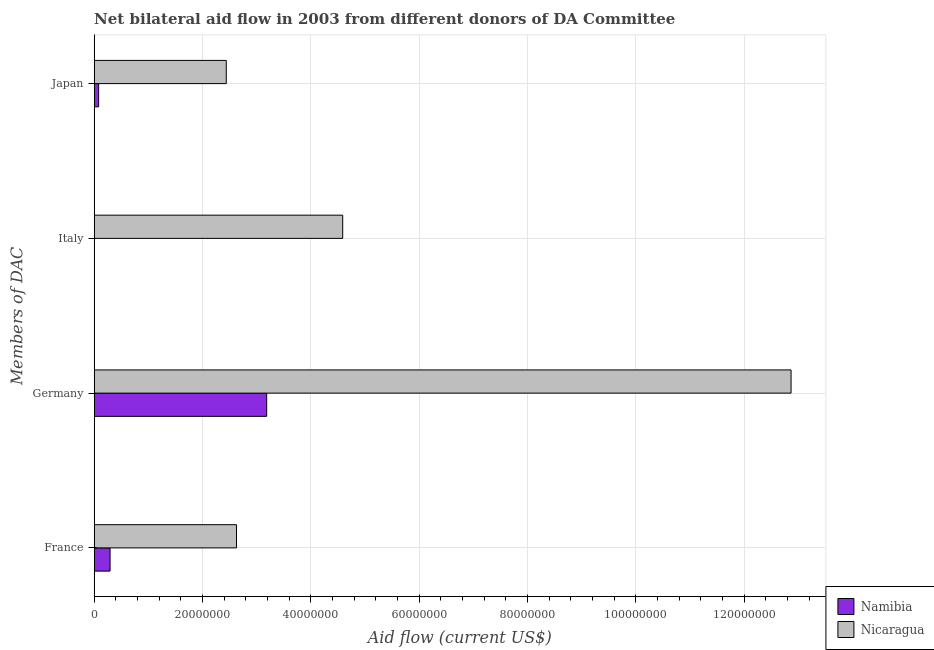How many bars are there on the 1st tick from the bottom?
Keep it short and to the point. 2. What is the label of the 3rd group of bars from the top?
Your answer should be very brief. Germany. What is the amount of aid given by germany in Namibia?
Ensure brevity in your answer.  3.18e+07. Across all countries, what is the maximum amount of aid given by france?
Offer a very short reply. 2.63e+07. Across all countries, what is the minimum amount of aid given by france?
Ensure brevity in your answer.  2.93e+06. In which country was the amount of aid given by japan maximum?
Give a very brief answer. Nicaragua. In which country was the amount of aid given by germany minimum?
Ensure brevity in your answer.  Namibia. What is the total amount of aid given by france in the graph?
Your response must be concise. 2.92e+07. What is the difference between the amount of aid given by italy in Nicaragua and that in Namibia?
Offer a terse response. 4.58e+07. What is the difference between the amount of aid given by japan in Nicaragua and the amount of aid given by france in Namibia?
Make the answer very short. 2.14e+07. What is the average amount of aid given by italy per country?
Give a very brief answer. 2.29e+07. What is the difference between the amount of aid given by germany and amount of aid given by france in Namibia?
Provide a succinct answer. 2.89e+07. What is the ratio of the amount of aid given by france in Namibia to that in Nicaragua?
Offer a very short reply. 0.11. Is the amount of aid given by france in Nicaragua less than that in Namibia?
Make the answer very short. No. Is the difference between the amount of aid given by italy in Nicaragua and Namibia greater than the difference between the amount of aid given by france in Nicaragua and Namibia?
Offer a very short reply. Yes. What is the difference between the highest and the second highest amount of aid given by italy?
Keep it short and to the point. 4.58e+07. What is the difference between the highest and the lowest amount of aid given by italy?
Your response must be concise. 4.58e+07. Is it the case that in every country, the sum of the amount of aid given by france and amount of aid given by japan is greater than the sum of amount of aid given by italy and amount of aid given by germany?
Offer a very short reply. No. What does the 2nd bar from the top in Japan represents?
Your answer should be very brief. Namibia. What does the 1st bar from the bottom in France represents?
Provide a succinct answer. Namibia. Is it the case that in every country, the sum of the amount of aid given by france and amount of aid given by germany is greater than the amount of aid given by italy?
Provide a succinct answer. Yes. How many bars are there?
Ensure brevity in your answer.  8. How many countries are there in the graph?
Offer a very short reply. 2. Are the values on the major ticks of X-axis written in scientific E-notation?
Offer a terse response. No. Does the graph contain grids?
Offer a terse response. Yes. How are the legend labels stacked?
Ensure brevity in your answer.  Vertical. What is the title of the graph?
Provide a succinct answer. Net bilateral aid flow in 2003 from different donors of DA Committee. Does "Papua New Guinea" appear as one of the legend labels in the graph?
Offer a terse response. No. What is the label or title of the X-axis?
Provide a short and direct response. Aid flow (current US$). What is the label or title of the Y-axis?
Ensure brevity in your answer.  Members of DAC. What is the Aid flow (current US$) of Namibia in France?
Provide a succinct answer. 2.93e+06. What is the Aid flow (current US$) of Nicaragua in France?
Make the answer very short. 2.63e+07. What is the Aid flow (current US$) in Namibia in Germany?
Offer a very short reply. 3.18e+07. What is the Aid flow (current US$) of Nicaragua in Germany?
Make the answer very short. 1.29e+08. What is the Aid flow (current US$) of Namibia in Italy?
Your answer should be compact. 2.00e+04. What is the Aid flow (current US$) of Nicaragua in Italy?
Give a very brief answer. 4.59e+07. What is the Aid flow (current US$) in Namibia in Japan?
Your answer should be compact. 8.20e+05. What is the Aid flow (current US$) in Nicaragua in Japan?
Your answer should be compact. 2.44e+07. Across all Members of DAC, what is the maximum Aid flow (current US$) of Namibia?
Offer a very short reply. 3.18e+07. Across all Members of DAC, what is the maximum Aid flow (current US$) in Nicaragua?
Ensure brevity in your answer.  1.29e+08. Across all Members of DAC, what is the minimum Aid flow (current US$) of Nicaragua?
Your response must be concise. 2.44e+07. What is the total Aid flow (current US$) in Namibia in the graph?
Make the answer very short. 3.56e+07. What is the total Aid flow (current US$) in Nicaragua in the graph?
Make the answer very short. 2.25e+08. What is the difference between the Aid flow (current US$) of Namibia in France and that in Germany?
Offer a terse response. -2.89e+07. What is the difference between the Aid flow (current US$) in Nicaragua in France and that in Germany?
Your response must be concise. -1.02e+08. What is the difference between the Aid flow (current US$) of Namibia in France and that in Italy?
Keep it short and to the point. 2.91e+06. What is the difference between the Aid flow (current US$) in Nicaragua in France and that in Italy?
Offer a very short reply. -1.96e+07. What is the difference between the Aid flow (current US$) of Namibia in France and that in Japan?
Give a very brief answer. 2.11e+06. What is the difference between the Aid flow (current US$) in Nicaragua in France and that in Japan?
Offer a very short reply. 1.89e+06. What is the difference between the Aid flow (current US$) of Namibia in Germany and that in Italy?
Offer a very short reply. 3.18e+07. What is the difference between the Aid flow (current US$) in Nicaragua in Germany and that in Italy?
Keep it short and to the point. 8.28e+07. What is the difference between the Aid flow (current US$) in Namibia in Germany and that in Japan?
Ensure brevity in your answer.  3.10e+07. What is the difference between the Aid flow (current US$) of Nicaragua in Germany and that in Japan?
Your answer should be compact. 1.04e+08. What is the difference between the Aid flow (current US$) of Namibia in Italy and that in Japan?
Keep it short and to the point. -8.00e+05. What is the difference between the Aid flow (current US$) of Nicaragua in Italy and that in Japan?
Your response must be concise. 2.15e+07. What is the difference between the Aid flow (current US$) in Namibia in France and the Aid flow (current US$) in Nicaragua in Germany?
Your answer should be compact. -1.26e+08. What is the difference between the Aid flow (current US$) of Namibia in France and the Aid flow (current US$) of Nicaragua in Italy?
Give a very brief answer. -4.29e+07. What is the difference between the Aid flow (current US$) in Namibia in France and the Aid flow (current US$) in Nicaragua in Japan?
Provide a short and direct response. -2.14e+07. What is the difference between the Aid flow (current US$) of Namibia in Germany and the Aid flow (current US$) of Nicaragua in Italy?
Offer a terse response. -1.40e+07. What is the difference between the Aid flow (current US$) of Namibia in Germany and the Aid flow (current US$) of Nicaragua in Japan?
Ensure brevity in your answer.  7.46e+06. What is the difference between the Aid flow (current US$) of Namibia in Italy and the Aid flow (current US$) of Nicaragua in Japan?
Your response must be concise. -2.44e+07. What is the average Aid flow (current US$) of Namibia per Members of DAC?
Give a very brief answer. 8.90e+06. What is the average Aid flow (current US$) of Nicaragua per Members of DAC?
Give a very brief answer. 5.63e+07. What is the difference between the Aid flow (current US$) of Namibia and Aid flow (current US$) of Nicaragua in France?
Give a very brief answer. -2.33e+07. What is the difference between the Aid flow (current US$) of Namibia and Aid flow (current US$) of Nicaragua in Germany?
Provide a short and direct response. -9.68e+07. What is the difference between the Aid flow (current US$) in Namibia and Aid flow (current US$) in Nicaragua in Italy?
Your answer should be compact. -4.58e+07. What is the difference between the Aid flow (current US$) of Namibia and Aid flow (current US$) of Nicaragua in Japan?
Offer a very short reply. -2.36e+07. What is the ratio of the Aid flow (current US$) in Namibia in France to that in Germany?
Offer a very short reply. 0.09. What is the ratio of the Aid flow (current US$) of Nicaragua in France to that in Germany?
Offer a very short reply. 0.2. What is the ratio of the Aid flow (current US$) of Namibia in France to that in Italy?
Your answer should be compact. 146.5. What is the ratio of the Aid flow (current US$) of Nicaragua in France to that in Italy?
Your response must be concise. 0.57. What is the ratio of the Aid flow (current US$) of Namibia in France to that in Japan?
Provide a succinct answer. 3.57. What is the ratio of the Aid flow (current US$) in Nicaragua in France to that in Japan?
Offer a terse response. 1.08. What is the ratio of the Aid flow (current US$) of Namibia in Germany to that in Italy?
Provide a short and direct response. 1592. What is the ratio of the Aid flow (current US$) of Nicaragua in Germany to that in Italy?
Give a very brief answer. 2.8. What is the ratio of the Aid flow (current US$) in Namibia in Germany to that in Japan?
Give a very brief answer. 38.83. What is the ratio of the Aid flow (current US$) of Nicaragua in Germany to that in Japan?
Provide a short and direct response. 5.28. What is the ratio of the Aid flow (current US$) of Namibia in Italy to that in Japan?
Ensure brevity in your answer.  0.02. What is the ratio of the Aid flow (current US$) of Nicaragua in Italy to that in Japan?
Your response must be concise. 1.88. What is the difference between the highest and the second highest Aid flow (current US$) in Namibia?
Offer a very short reply. 2.89e+07. What is the difference between the highest and the second highest Aid flow (current US$) in Nicaragua?
Offer a terse response. 8.28e+07. What is the difference between the highest and the lowest Aid flow (current US$) of Namibia?
Keep it short and to the point. 3.18e+07. What is the difference between the highest and the lowest Aid flow (current US$) in Nicaragua?
Give a very brief answer. 1.04e+08. 